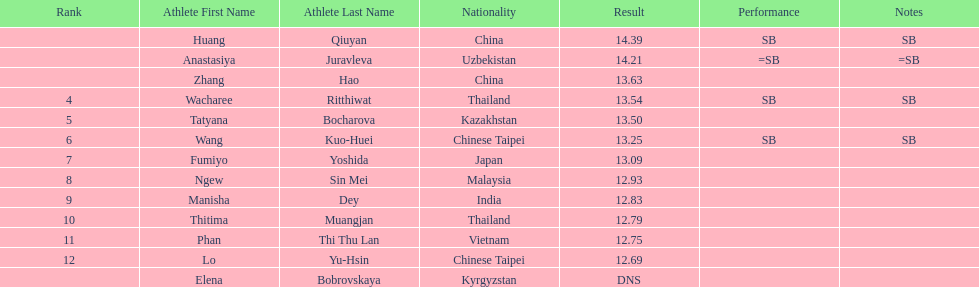Which country came in first? China. 